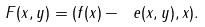Convert formula to latex. <formula><loc_0><loc_0><loc_500><loc_500>F ( x , y ) = ( f ( x ) - \ e ( x , y ) , x ) .</formula> 